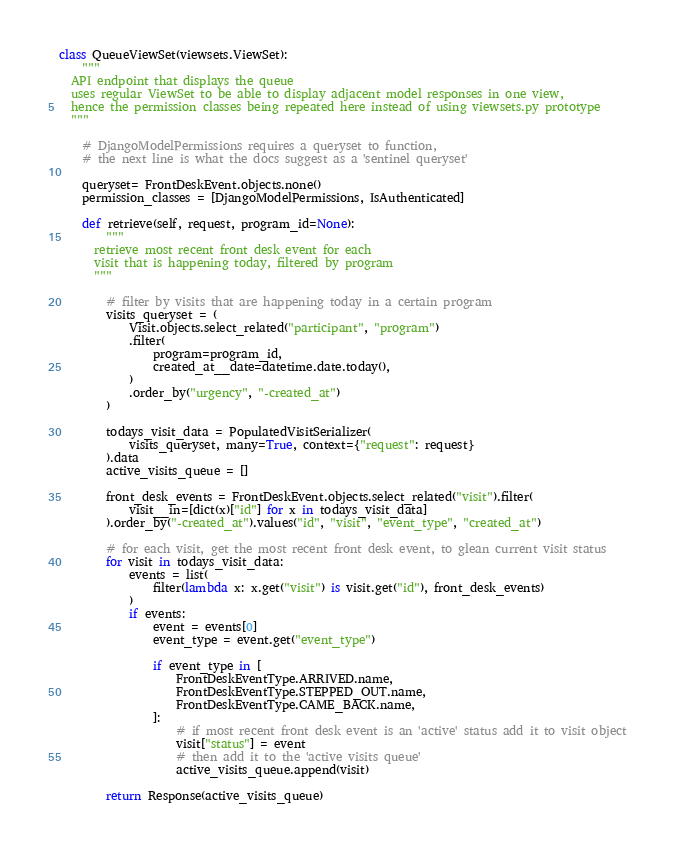Convert code to text. <code><loc_0><loc_0><loc_500><loc_500><_Python_>
class QueueViewSet(viewsets.ViewSet):
    """
  API endpoint that displays the queue
  uses regular ViewSet to be able to display adjacent model responses in one view,
  hence the permission classes being repeated here instead of using viewsets.py prototype
  """

    # DjangoModelPermissions requires a queryset to function,
    # the next line is what the docs suggest as a 'sentinel queryset'

    queryset= FrontDeskEvent.objects.none()
    permission_classes = [DjangoModelPermissions, IsAuthenticated]

    def retrieve(self, request, program_id=None):
        """
      retrieve most recent front desk event for each
      visit that is happening today, filtered by program
      """

        # filter by visits that are happening today in a certain program
        visits_queryset = (
            Visit.objects.select_related("participant", "program")
            .filter(
                program=program_id,
                created_at__date=datetime.date.today(),
            )
            .order_by("urgency", "-created_at")
        )

        todays_visit_data = PopulatedVisitSerializer(
            visits_queryset, many=True, context={"request": request}
        ).data
        active_visits_queue = []

        front_desk_events = FrontDeskEvent.objects.select_related("visit").filter(
            visit__in=[dict(x)["id"] for x in todays_visit_data]
        ).order_by("-created_at").values("id", "visit", "event_type", "created_at")

        # for each visit, get the most recent front desk event, to glean current visit status
        for visit in todays_visit_data:
            events = list(
                filter(lambda x: x.get("visit") is visit.get("id"), front_desk_events)
            )
            if events:
                event = events[0]
                event_type = event.get("event_type")

                if event_type in [
                    FrontDeskEventType.ARRIVED.name,
                    FrontDeskEventType.STEPPED_OUT.name,
                    FrontDeskEventType.CAME_BACK.name,
                ]:
                    # if most recent front desk event is an 'active' status add it to visit object
                    visit["status"] = event
                    # then add it to the 'active visits queue'
                    active_visits_queue.append(visit)

        return Response(active_visits_queue)
</code> 